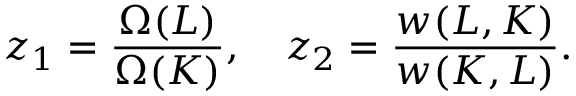<formula> <loc_0><loc_0><loc_500><loc_500>z _ { 1 } = \frac { \Omega ( L ) } { \Omega ( K ) } , \quad z _ { 2 } = \frac { w ( L , K ) } { w ( K , L ) } .</formula> 